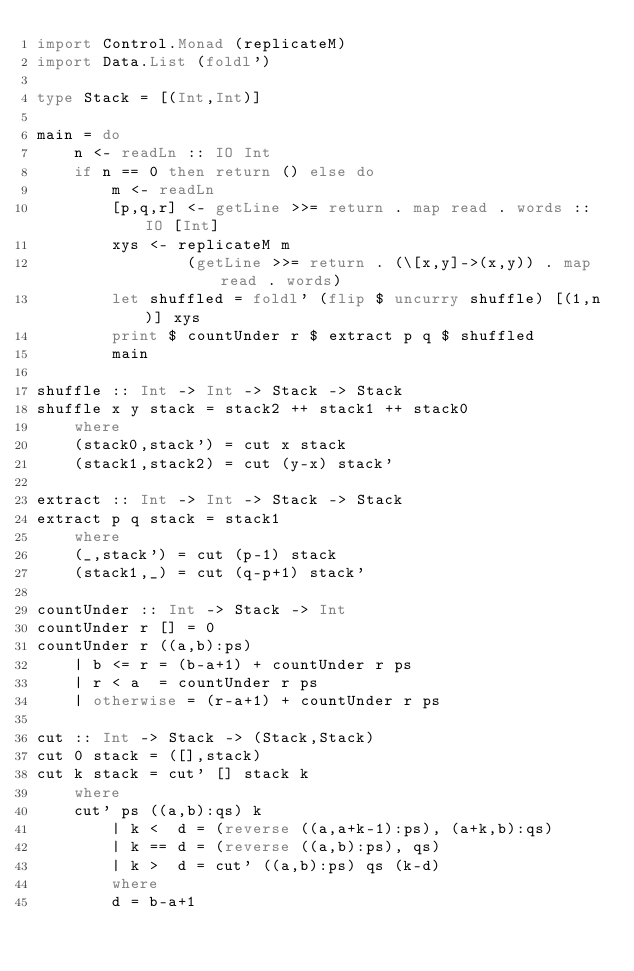<code> <loc_0><loc_0><loc_500><loc_500><_Haskell_>import Control.Monad (replicateM)
import Data.List (foldl')

type Stack = [(Int,Int)]

main = do
    n <- readLn :: IO Int
    if n == 0 then return () else do
        m <- readLn
        [p,q,r] <- getLine >>= return . map read . words :: IO [Int]
        xys <- replicateM m
                (getLine >>= return . (\[x,y]->(x,y)) . map read . words)
        let shuffled = foldl' (flip $ uncurry shuffle) [(1,n)] xys
        print $ countUnder r $ extract p q $ shuffled
        main

shuffle :: Int -> Int -> Stack -> Stack
shuffle x y stack = stack2 ++ stack1 ++ stack0
    where
    (stack0,stack') = cut x stack
    (stack1,stack2) = cut (y-x) stack'

extract :: Int -> Int -> Stack -> Stack
extract p q stack = stack1
    where
    (_,stack') = cut (p-1) stack
    (stack1,_) = cut (q-p+1) stack'

countUnder :: Int -> Stack -> Int
countUnder r [] = 0
countUnder r ((a,b):ps)
    | b <= r = (b-a+1) + countUnder r ps
    | r < a  = countUnder r ps
    | otherwise = (r-a+1) + countUnder r ps

cut :: Int -> Stack -> (Stack,Stack)
cut 0 stack = ([],stack)
cut k stack = cut' [] stack k
    where
    cut' ps ((a,b):qs) k
        | k <  d = (reverse ((a,a+k-1):ps), (a+k,b):qs)
        | k == d = (reverse ((a,b):ps), qs)
        | k >  d = cut' ((a,b):ps) qs (k-d)
        where
        d = b-a+1</code> 